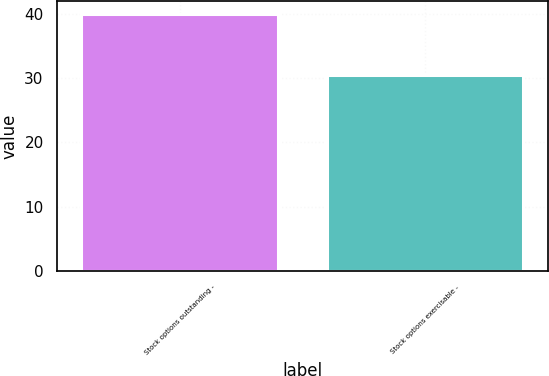<chart> <loc_0><loc_0><loc_500><loc_500><bar_chart><fcel>Stock options outstanding -<fcel>Stock options exercisable -<nl><fcel>40<fcel>30.53<nl></chart> 